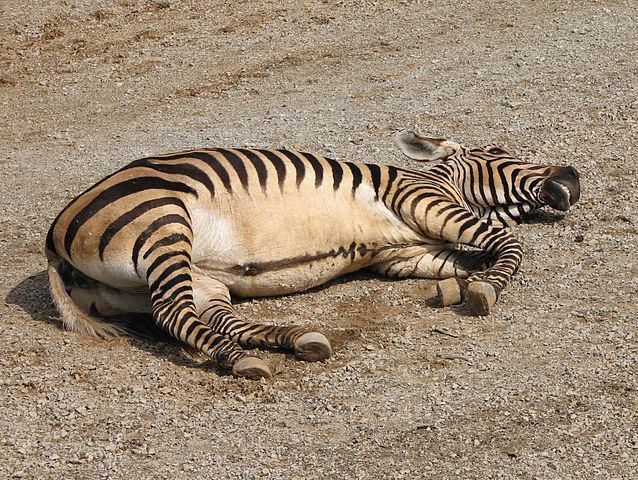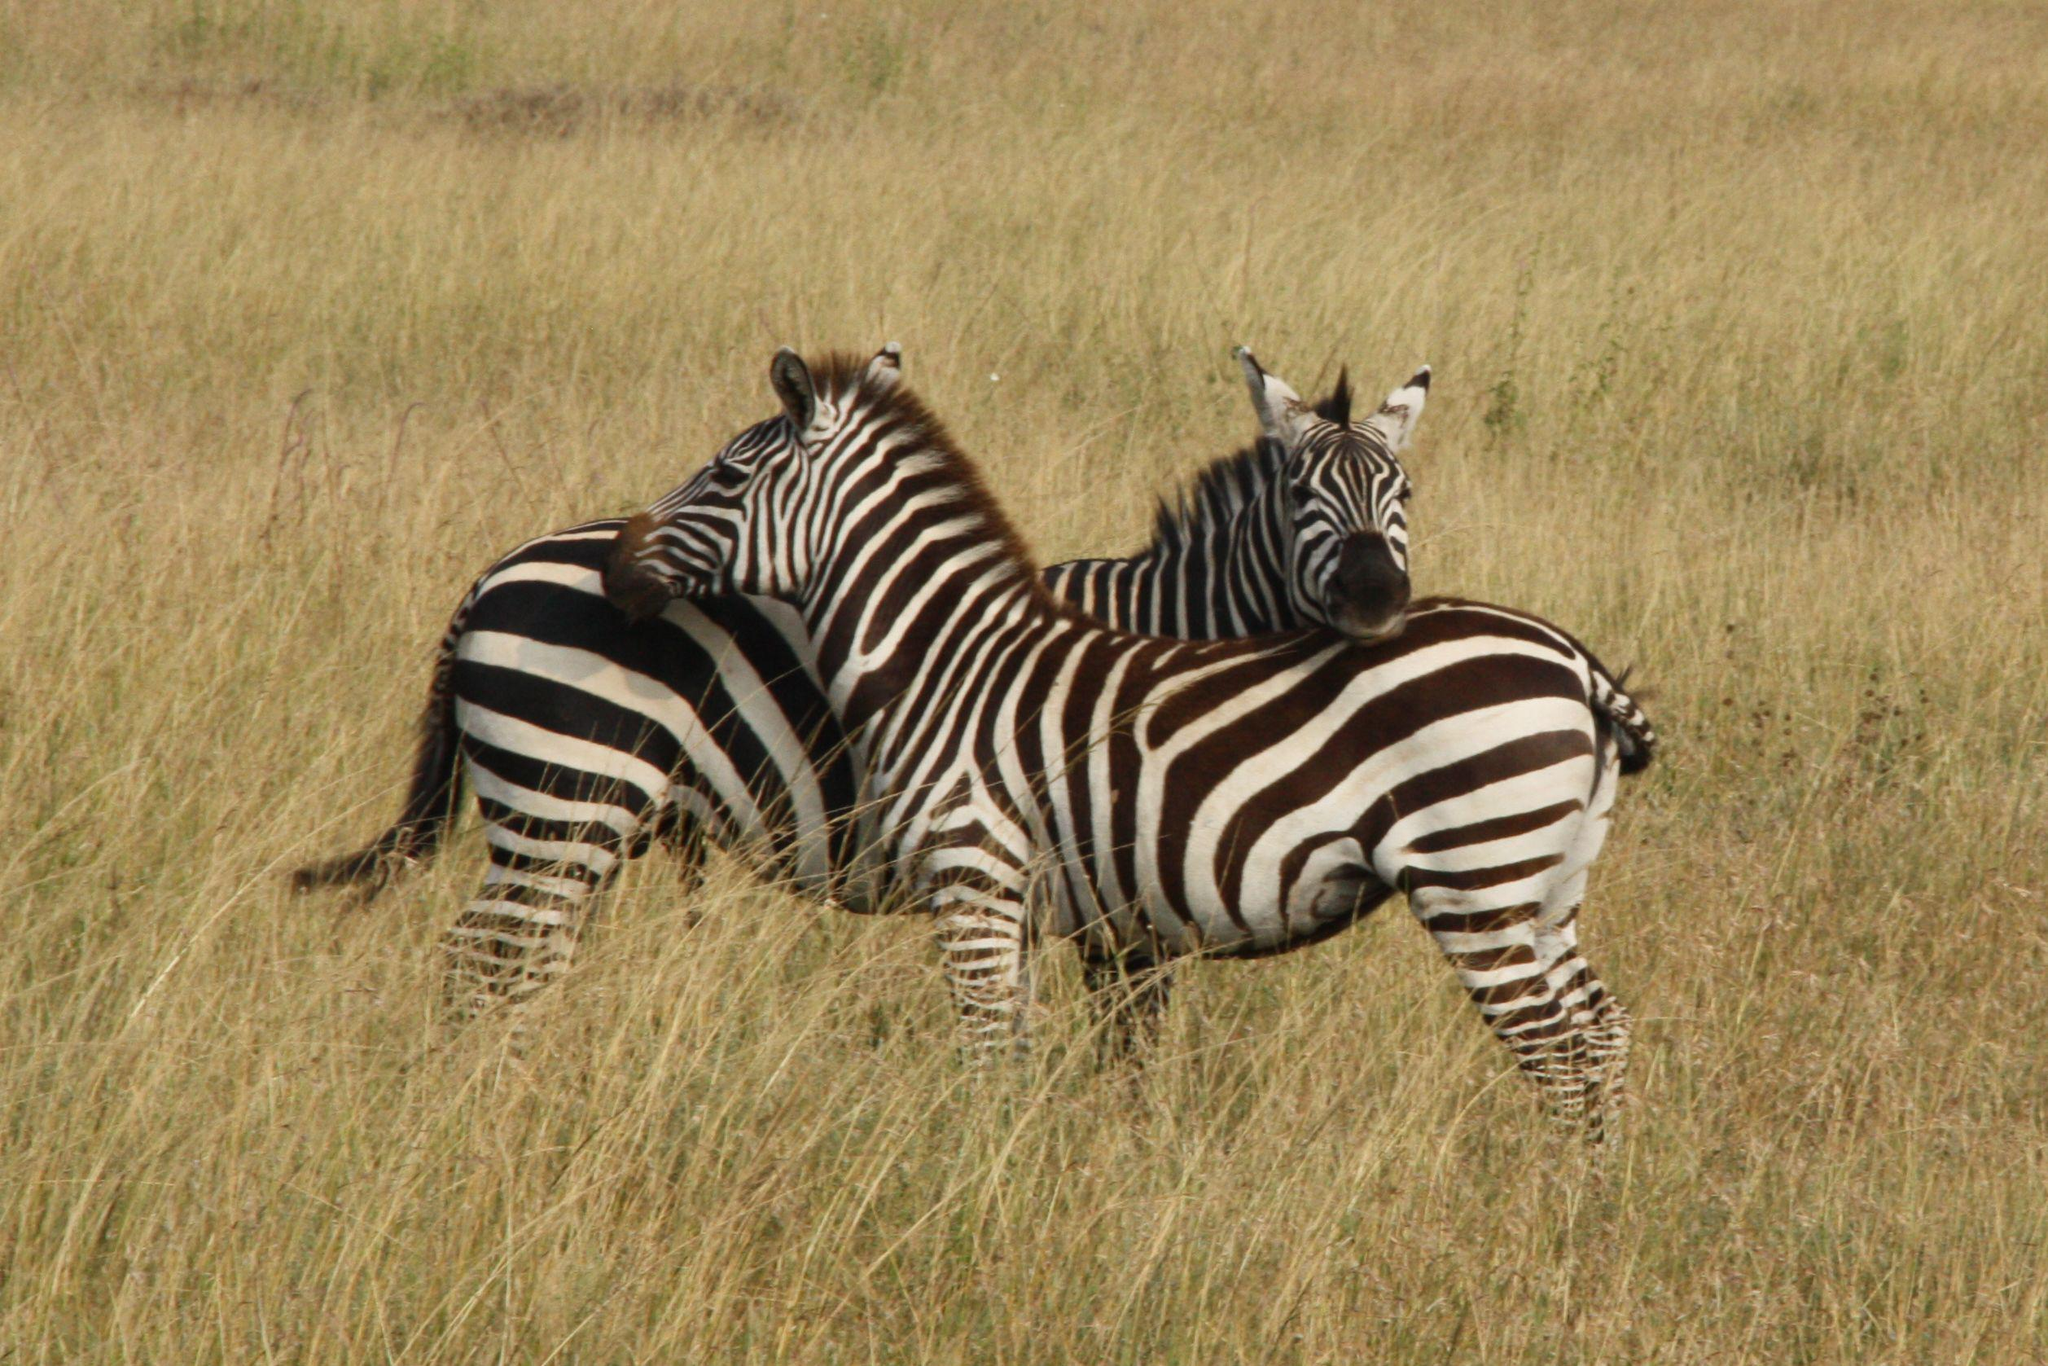The first image is the image on the left, the second image is the image on the right. Considering the images on both sides, is "The right image shows one zebra reclining on the ground with its front legs folded under its body." valid? Answer yes or no. No. The first image is the image on the left, the second image is the image on the right. Assess this claim about the two images: "The left and right image contains a total of three zebras.". Correct or not? Answer yes or no. Yes. 